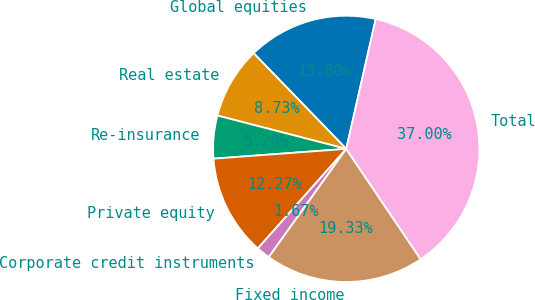Convert chart. <chart><loc_0><loc_0><loc_500><loc_500><pie_chart><fcel>Global equities<fcel>Real estate<fcel>Re-insurance<fcel>Private equity<fcel>Corporate credit instruments<fcel>Fixed income<fcel>Total<nl><fcel>15.8%<fcel>8.73%<fcel>5.2%<fcel>12.27%<fcel>1.67%<fcel>19.33%<fcel>37.0%<nl></chart> 